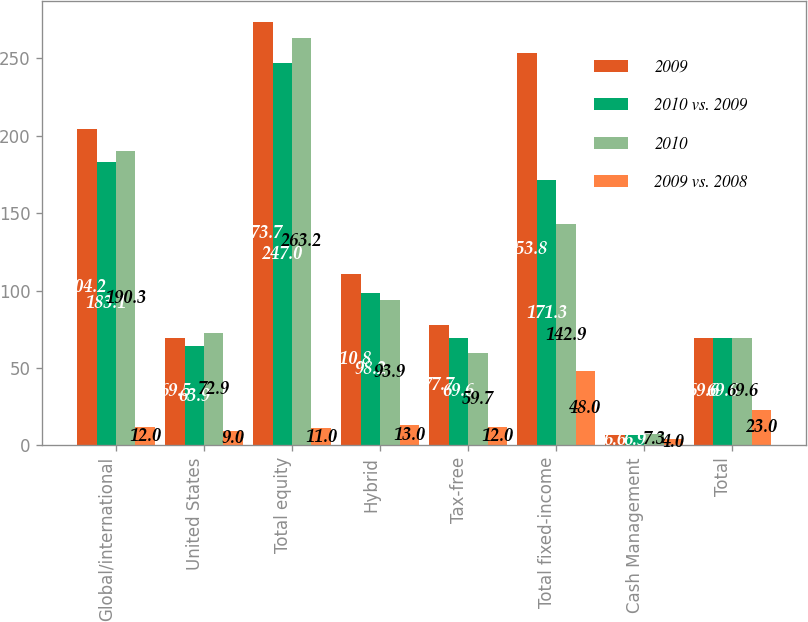Convert chart to OTSL. <chart><loc_0><loc_0><loc_500><loc_500><stacked_bar_chart><ecel><fcel>Global/international<fcel>United States<fcel>Total equity<fcel>Hybrid<fcel>Tax-free<fcel>Total fixed-income<fcel>Cash Management<fcel>Total<nl><fcel>2009<fcel>204.2<fcel>69.5<fcel>273.7<fcel>110.8<fcel>77.7<fcel>253.8<fcel>6.6<fcel>69.6<nl><fcel>2010 vs. 2009<fcel>183.1<fcel>63.9<fcel>247<fcel>98.2<fcel>69.6<fcel>171.3<fcel>6.9<fcel>69.6<nl><fcel>2010<fcel>190.3<fcel>72.9<fcel>263.2<fcel>93.9<fcel>59.7<fcel>142.9<fcel>7.3<fcel>69.6<nl><fcel>2009 vs. 2008<fcel>12<fcel>9<fcel>11<fcel>13<fcel>12<fcel>48<fcel>4<fcel>23<nl></chart> 